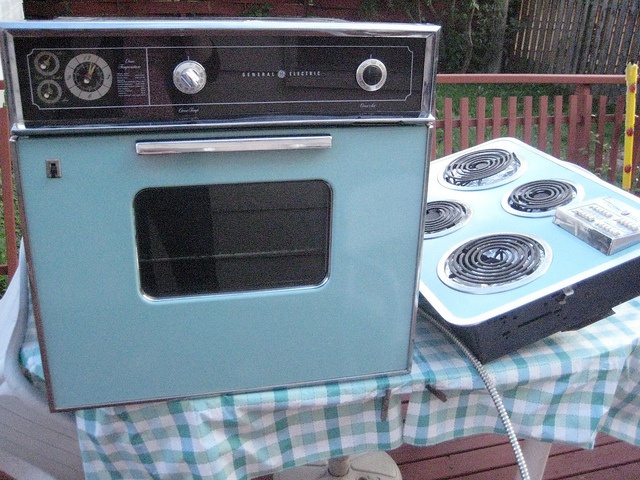Describe the objects in this image and their specific colors. I can see oven in lightgray, darkgray, black, gray, and lightblue tones and clock in lightgray, gray, and black tones in this image. 